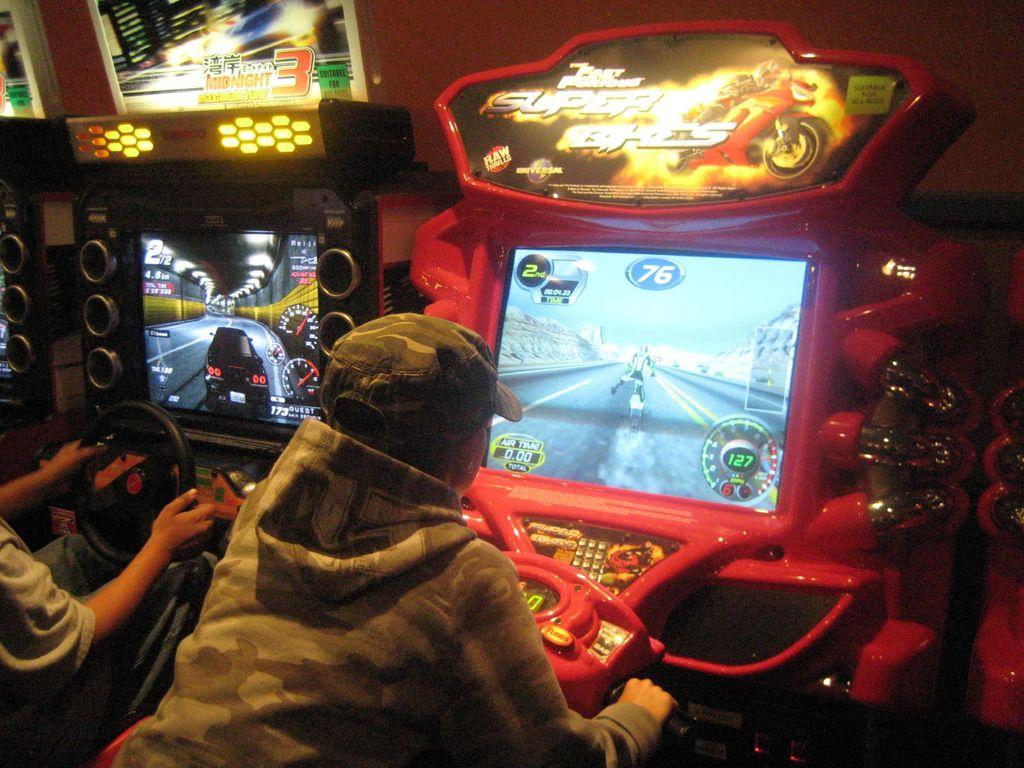Who is present in the image? There are people in the image. What are the people doing in the image? The people are playing video games. What devices are the people using to play the video games? There are monitors in front of the people. How many cherries are on the goose in the image? There is no goose or cherries present in the image. What color is the bead that the person is holding in the image? There is no bead present in the image; the people are playing video games using monitors. 